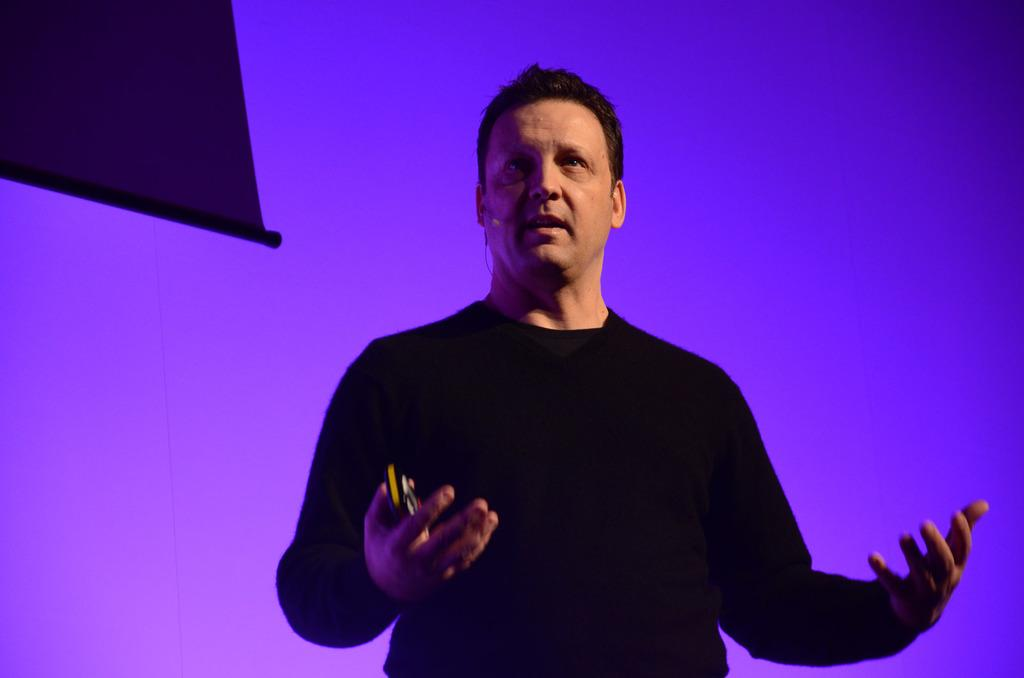Who is present in the image? There is a person in the image. What is the person holding in their hand? The person is holding an object in their hand. What can be seen in the background of the image? There is a board in the background of the image, which has purple and blue colors. Where might the image have been taken? The image may have been taken in a hall. What advice does the person's grandfather give them in the image? There is no mention of a grandfather or any advice in the image. 